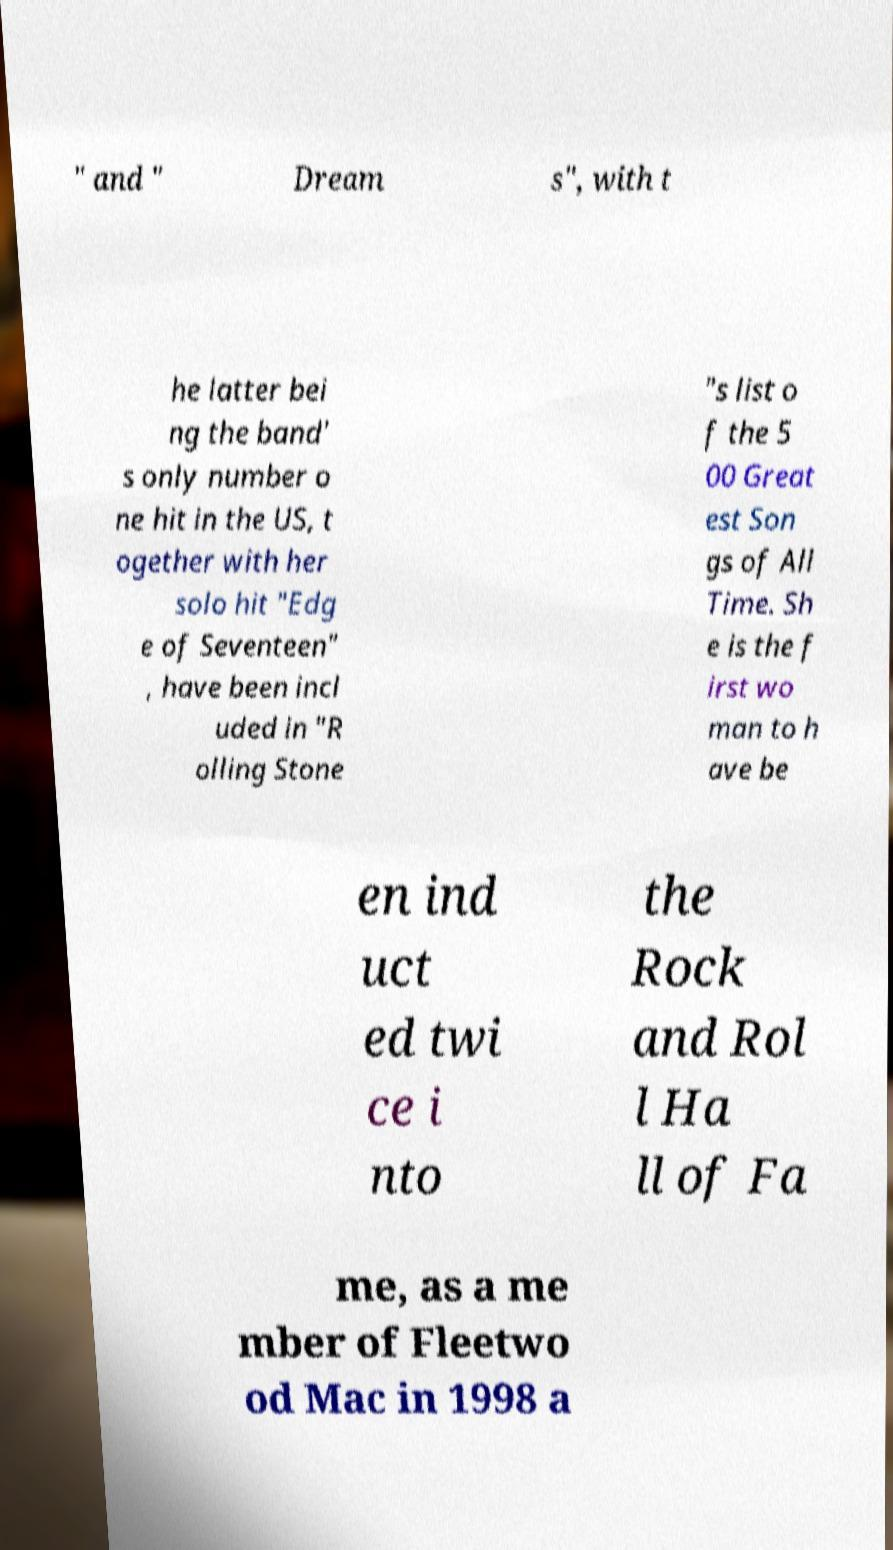Please read and relay the text visible in this image. What does it say? " and " Dream s", with t he latter bei ng the band' s only number o ne hit in the US, t ogether with her solo hit "Edg e of Seventeen" , have been incl uded in "R olling Stone "s list o f the 5 00 Great est Son gs of All Time. Sh e is the f irst wo man to h ave be en ind uct ed twi ce i nto the Rock and Rol l Ha ll of Fa me, as a me mber of Fleetwo od Mac in 1998 a 